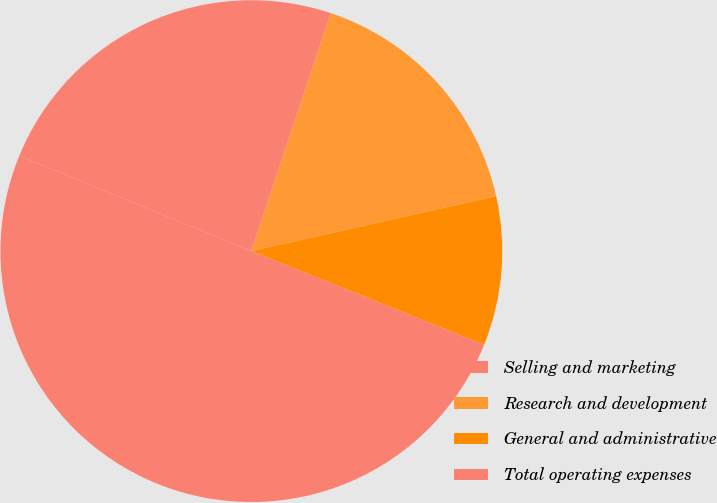<chart> <loc_0><loc_0><loc_500><loc_500><pie_chart><fcel>Selling and marketing<fcel>Research and development<fcel>General and administrative<fcel>Total operating expenses<nl><fcel>23.92%<fcel>16.35%<fcel>9.61%<fcel>50.11%<nl></chart> 